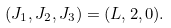<formula> <loc_0><loc_0><loc_500><loc_500>( J _ { 1 } , J _ { 2 } , J _ { 3 } ) = ( L , 2 , 0 ) .</formula> 